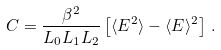Convert formula to latex. <formula><loc_0><loc_0><loc_500><loc_500>C = \frac { \beta ^ { 2 } } { L _ { 0 } L _ { 1 } L _ { 2 } } \left [ \langle E ^ { 2 } \rangle - \langle E \rangle ^ { 2 } \right ] \, .</formula> 